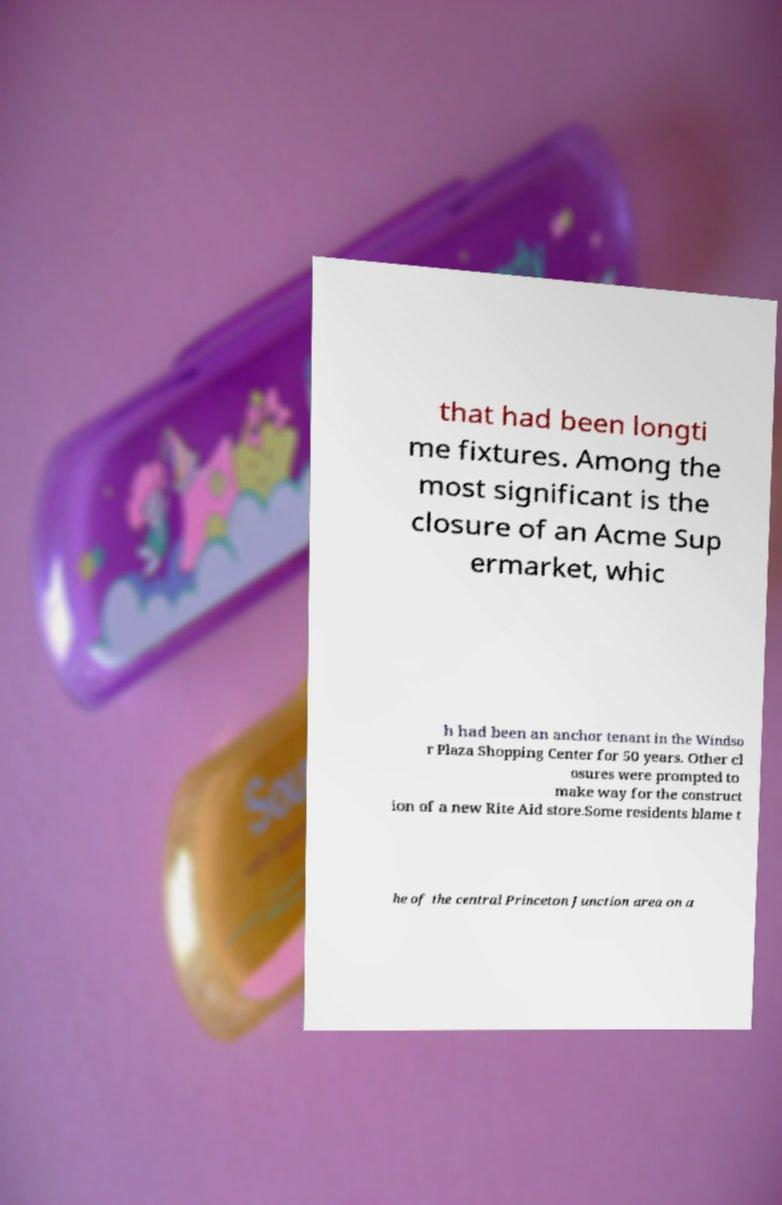There's text embedded in this image that I need extracted. Can you transcribe it verbatim? that had been longti me fixtures. Among the most significant is the closure of an Acme Sup ermarket, whic h had been an anchor tenant in the Windso r Plaza Shopping Center for 50 years. Other cl osures were prompted to make way for the construct ion of a new Rite Aid store.Some residents blame t he of the central Princeton Junction area on a 